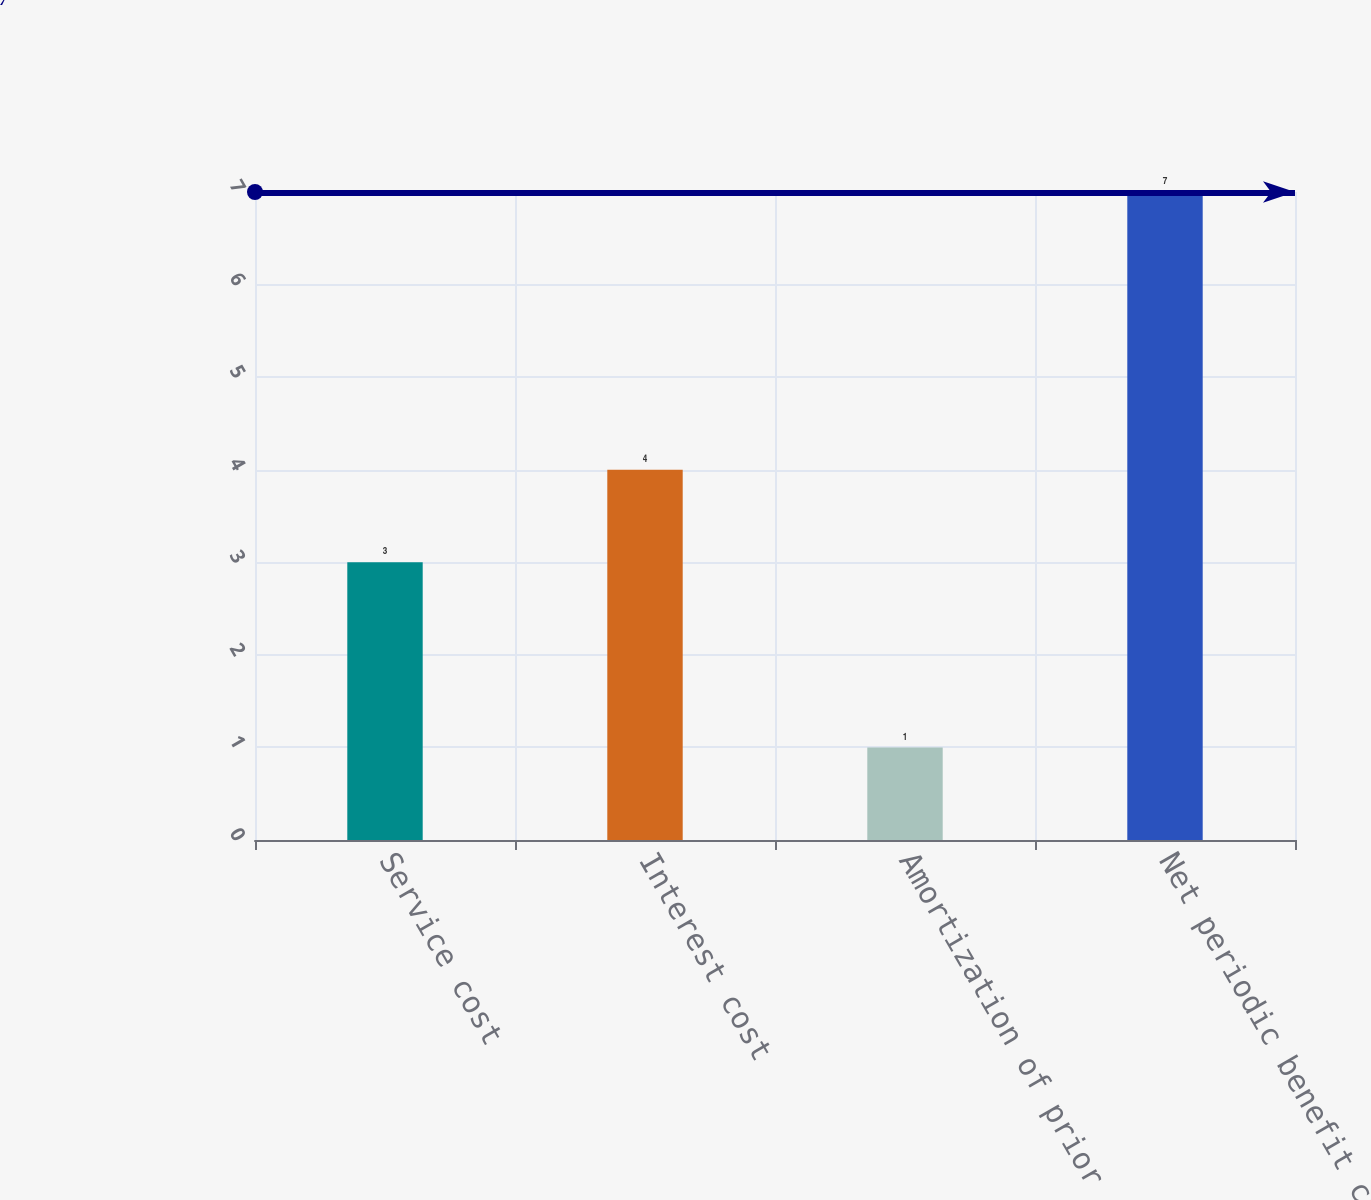Convert chart to OTSL. <chart><loc_0><loc_0><loc_500><loc_500><bar_chart><fcel>Service cost<fcel>Interest cost<fcel>Amortization of prior service<fcel>Net periodic benefit cost<nl><fcel>3<fcel>4<fcel>1<fcel>7<nl></chart> 